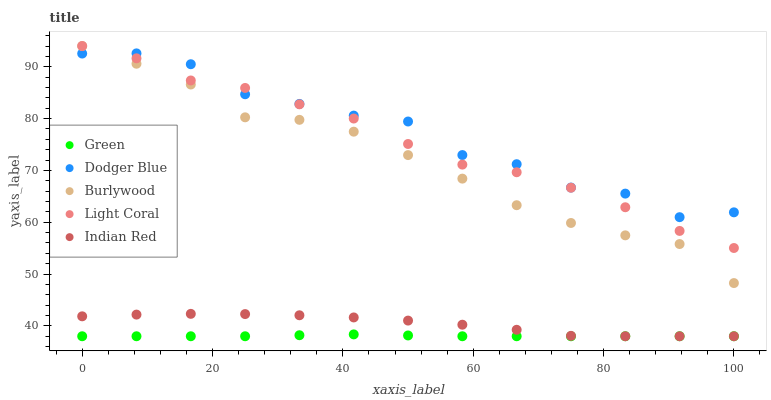Does Green have the minimum area under the curve?
Answer yes or no. Yes. Does Dodger Blue have the maximum area under the curve?
Answer yes or no. Yes. Does Dodger Blue have the minimum area under the curve?
Answer yes or no. No. Does Green have the maximum area under the curve?
Answer yes or no. No. Is Green the smoothest?
Answer yes or no. Yes. Is Dodger Blue the roughest?
Answer yes or no. Yes. Is Dodger Blue the smoothest?
Answer yes or no. No. Is Green the roughest?
Answer yes or no. No. Does Green have the lowest value?
Answer yes or no. Yes. Does Dodger Blue have the lowest value?
Answer yes or no. No. Does Light Coral have the highest value?
Answer yes or no. Yes. Does Dodger Blue have the highest value?
Answer yes or no. No. Is Green less than Dodger Blue?
Answer yes or no. Yes. Is Light Coral greater than Green?
Answer yes or no. Yes. Does Burlywood intersect Light Coral?
Answer yes or no. Yes. Is Burlywood less than Light Coral?
Answer yes or no. No. Is Burlywood greater than Light Coral?
Answer yes or no. No. Does Green intersect Dodger Blue?
Answer yes or no. No. 